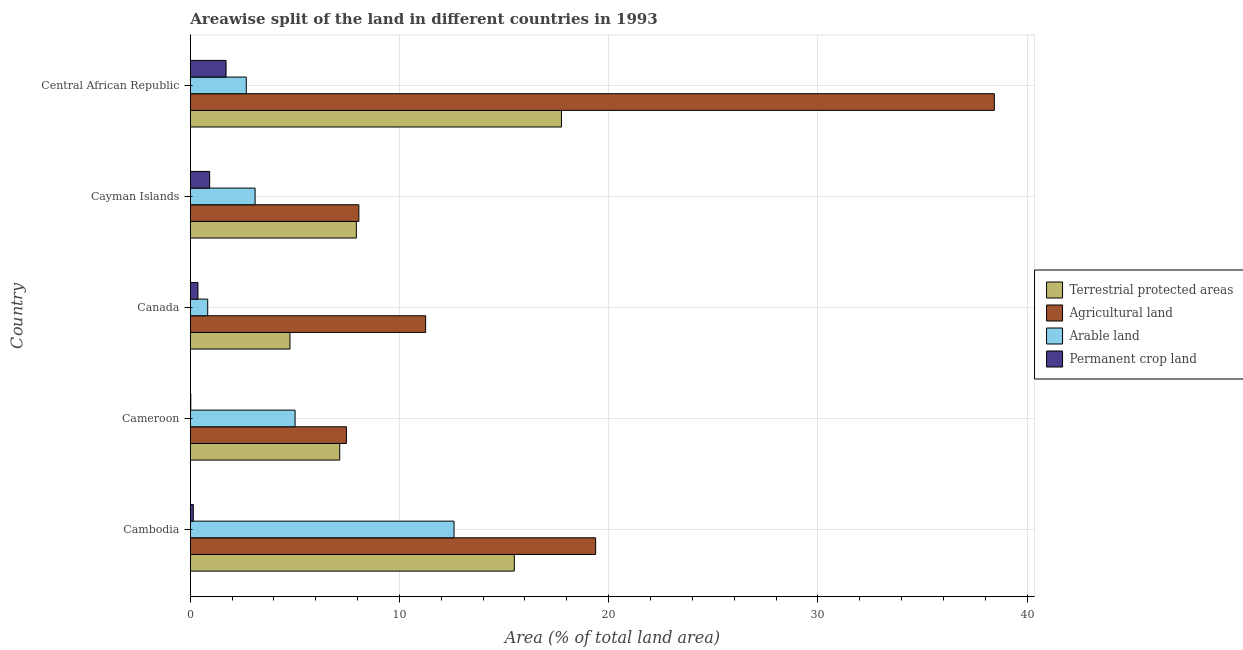How many different coloured bars are there?
Your answer should be compact. 4. How many groups of bars are there?
Your answer should be very brief. 5. Are the number of bars per tick equal to the number of legend labels?
Give a very brief answer. Yes. Are the number of bars on each tick of the Y-axis equal?
Keep it short and to the point. Yes. What is the label of the 1st group of bars from the top?
Your response must be concise. Central African Republic. In how many cases, is the number of bars for a given country not equal to the number of legend labels?
Keep it short and to the point. 0. What is the percentage of area under arable land in Cayman Islands?
Keep it short and to the point. 3.1. Across all countries, what is the maximum percentage of area under arable land?
Provide a short and direct response. 12.61. Across all countries, what is the minimum percentage of area under agricultural land?
Offer a terse response. 7.46. In which country was the percentage of area under arable land maximum?
Provide a succinct answer. Cambodia. In which country was the percentage of land under terrestrial protection minimum?
Provide a short and direct response. Canada. What is the total percentage of area under arable land in the graph?
Make the answer very short. 24.23. What is the difference between the percentage of area under agricultural land in Cambodia and that in Canada?
Your answer should be compact. 8.13. What is the difference between the percentage of land under terrestrial protection in Central African Republic and the percentage of area under agricultural land in Cambodia?
Your answer should be compact. -1.63. What is the average percentage of area under permanent crop land per country?
Keep it short and to the point. 0.63. What is the difference between the percentage of land under terrestrial protection and percentage of area under permanent crop land in Canada?
Keep it short and to the point. 4.4. In how many countries, is the percentage of area under agricultural land greater than 22 %?
Give a very brief answer. 1. What is the ratio of the percentage of area under permanent crop land in Canada to that in Central African Republic?
Keep it short and to the point. 0.21. Is the difference between the percentage of area under agricultural land in Canada and Cayman Islands greater than the difference between the percentage of area under arable land in Canada and Cayman Islands?
Give a very brief answer. Yes. What is the difference between the highest and the second highest percentage of area under arable land?
Your answer should be very brief. 7.6. What is the difference between the highest and the lowest percentage of area under agricultural land?
Offer a very short reply. 30.97. Is the sum of the percentage of land under terrestrial protection in Canada and Central African Republic greater than the maximum percentage of area under arable land across all countries?
Offer a terse response. Yes. What does the 1st bar from the top in Cayman Islands represents?
Make the answer very short. Permanent crop land. What does the 3rd bar from the bottom in Canada represents?
Your answer should be compact. Arable land. How many bars are there?
Your answer should be compact. 20. How many countries are there in the graph?
Give a very brief answer. 5. Does the graph contain grids?
Provide a short and direct response. Yes. What is the title of the graph?
Provide a short and direct response. Areawise split of the land in different countries in 1993. What is the label or title of the X-axis?
Make the answer very short. Area (% of total land area). What is the Area (% of total land area) of Terrestrial protected areas in Cambodia?
Your response must be concise. 15.49. What is the Area (% of total land area) of Agricultural land in Cambodia?
Offer a terse response. 19.38. What is the Area (% of total land area) of Arable land in Cambodia?
Provide a succinct answer. 12.61. What is the Area (% of total land area) of Permanent crop land in Cambodia?
Offer a terse response. 0.14. What is the Area (% of total land area) in Terrestrial protected areas in Cameroon?
Provide a succinct answer. 7.14. What is the Area (% of total land area) of Agricultural land in Cameroon?
Provide a succinct answer. 7.46. What is the Area (% of total land area) of Arable land in Cameroon?
Your response must be concise. 5.01. What is the Area (% of total land area) in Permanent crop land in Cameroon?
Your answer should be compact. 0.02. What is the Area (% of total land area) of Terrestrial protected areas in Canada?
Give a very brief answer. 4.77. What is the Area (% of total land area) in Agricultural land in Canada?
Keep it short and to the point. 11.25. What is the Area (% of total land area) in Arable land in Canada?
Make the answer very short. 0.83. What is the Area (% of total land area) of Permanent crop land in Canada?
Your answer should be compact. 0.37. What is the Area (% of total land area) in Terrestrial protected areas in Cayman Islands?
Your answer should be compact. 7.94. What is the Area (% of total land area) in Agricultural land in Cayman Islands?
Make the answer very short. 8.06. What is the Area (% of total land area) in Arable land in Cayman Islands?
Make the answer very short. 3.1. What is the Area (% of total land area) in Permanent crop land in Cayman Islands?
Keep it short and to the point. 0.93. What is the Area (% of total land area) of Terrestrial protected areas in Central African Republic?
Offer a terse response. 17.74. What is the Area (% of total land area) of Agricultural land in Central African Republic?
Your response must be concise. 38.44. What is the Area (% of total land area) of Arable land in Central African Republic?
Provide a short and direct response. 2.68. What is the Area (% of total land area) in Permanent crop land in Central African Republic?
Keep it short and to the point. 1.71. Across all countries, what is the maximum Area (% of total land area) in Terrestrial protected areas?
Keep it short and to the point. 17.74. Across all countries, what is the maximum Area (% of total land area) in Agricultural land?
Make the answer very short. 38.44. Across all countries, what is the maximum Area (% of total land area) in Arable land?
Your answer should be compact. 12.61. Across all countries, what is the maximum Area (% of total land area) of Permanent crop land?
Give a very brief answer. 1.71. Across all countries, what is the minimum Area (% of total land area) of Terrestrial protected areas?
Ensure brevity in your answer.  4.77. Across all countries, what is the minimum Area (% of total land area) in Agricultural land?
Provide a short and direct response. 7.46. Across all countries, what is the minimum Area (% of total land area) of Arable land?
Your answer should be very brief. 0.83. Across all countries, what is the minimum Area (% of total land area) of Permanent crop land?
Your answer should be very brief. 0.02. What is the total Area (% of total land area) of Terrestrial protected areas in the graph?
Your answer should be very brief. 53.08. What is the total Area (% of total land area) of Agricultural land in the graph?
Offer a terse response. 84.59. What is the total Area (% of total land area) in Arable land in the graph?
Make the answer very short. 24.23. What is the total Area (% of total land area) of Permanent crop land in the graph?
Give a very brief answer. 3.17. What is the difference between the Area (% of total land area) in Terrestrial protected areas in Cambodia and that in Cameroon?
Offer a terse response. 8.35. What is the difference between the Area (% of total land area) in Agricultural land in Cambodia and that in Cameroon?
Provide a succinct answer. 11.91. What is the difference between the Area (% of total land area) in Arable land in Cambodia and that in Cameroon?
Make the answer very short. 7.6. What is the difference between the Area (% of total land area) of Permanent crop land in Cambodia and that in Cameroon?
Offer a very short reply. 0.12. What is the difference between the Area (% of total land area) in Terrestrial protected areas in Cambodia and that in Canada?
Keep it short and to the point. 10.72. What is the difference between the Area (% of total land area) in Agricultural land in Cambodia and that in Canada?
Offer a very short reply. 8.13. What is the difference between the Area (% of total land area) of Arable land in Cambodia and that in Canada?
Ensure brevity in your answer.  11.77. What is the difference between the Area (% of total land area) of Permanent crop land in Cambodia and that in Canada?
Keep it short and to the point. -0.22. What is the difference between the Area (% of total land area) in Terrestrial protected areas in Cambodia and that in Cayman Islands?
Your answer should be very brief. 7.55. What is the difference between the Area (% of total land area) in Agricultural land in Cambodia and that in Cayman Islands?
Offer a very short reply. 11.32. What is the difference between the Area (% of total land area) in Arable land in Cambodia and that in Cayman Islands?
Ensure brevity in your answer.  9.51. What is the difference between the Area (% of total land area) in Permanent crop land in Cambodia and that in Cayman Islands?
Give a very brief answer. -0.78. What is the difference between the Area (% of total land area) in Terrestrial protected areas in Cambodia and that in Central African Republic?
Your response must be concise. -2.25. What is the difference between the Area (% of total land area) of Agricultural land in Cambodia and that in Central African Republic?
Your answer should be very brief. -19.06. What is the difference between the Area (% of total land area) of Arable land in Cambodia and that in Central African Republic?
Provide a short and direct response. 9.93. What is the difference between the Area (% of total land area) of Permanent crop land in Cambodia and that in Central African Republic?
Ensure brevity in your answer.  -1.57. What is the difference between the Area (% of total land area) in Terrestrial protected areas in Cameroon and that in Canada?
Provide a short and direct response. 2.38. What is the difference between the Area (% of total land area) of Agricultural land in Cameroon and that in Canada?
Your answer should be compact. -3.79. What is the difference between the Area (% of total land area) of Arable land in Cameroon and that in Canada?
Your answer should be compact. 4.18. What is the difference between the Area (% of total land area) in Permanent crop land in Cameroon and that in Canada?
Make the answer very short. -0.34. What is the difference between the Area (% of total land area) in Terrestrial protected areas in Cameroon and that in Cayman Islands?
Your answer should be very brief. -0.79. What is the difference between the Area (% of total land area) in Agricultural land in Cameroon and that in Cayman Islands?
Ensure brevity in your answer.  -0.59. What is the difference between the Area (% of total land area) in Arable land in Cameroon and that in Cayman Islands?
Offer a very short reply. 1.91. What is the difference between the Area (% of total land area) of Permanent crop land in Cameroon and that in Cayman Islands?
Your response must be concise. -0.9. What is the difference between the Area (% of total land area) of Terrestrial protected areas in Cameroon and that in Central African Republic?
Your response must be concise. -10.6. What is the difference between the Area (% of total land area) of Agricultural land in Cameroon and that in Central African Republic?
Keep it short and to the point. -30.97. What is the difference between the Area (% of total land area) in Arable land in Cameroon and that in Central African Republic?
Your answer should be very brief. 2.33. What is the difference between the Area (% of total land area) of Permanent crop land in Cameroon and that in Central African Republic?
Ensure brevity in your answer.  -1.69. What is the difference between the Area (% of total land area) in Terrestrial protected areas in Canada and that in Cayman Islands?
Your answer should be compact. -3.17. What is the difference between the Area (% of total land area) of Agricultural land in Canada and that in Cayman Islands?
Keep it short and to the point. 3.19. What is the difference between the Area (% of total land area) in Arable land in Canada and that in Cayman Islands?
Ensure brevity in your answer.  -2.26. What is the difference between the Area (% of total land area) in Permanent crop land in Canada and that in Cayman Islands?
Ensure brevity in your answer.  -0.56. What is the difference between the Area (% of total land area) in Terrestrial protected areas in Canada and that in Central African Republic?
Offer a very short reply. -12.98. What is the difference between the Area (% of total land area) in Agricultural land in Canada and that in Central African Republic?
Ensure brevity in your answer.  -27.19. What is the difference between the Area (% of total land area) of Arable land in Canada and that in Central African Republic?
Your answer should be very brief. -1.84. What is the difference between the Area (% of total land area) in Permanent crop land in Canada and that in Central African Republic?
Provide a short and direct response. -1.34. What is the difference between the Area (% of total land area) in Terrestrial protected areas in Cayman Islands and that in Central African Republic?
Offer a very short reply. -9.81. What is the difference between the Area (% of total land area) in Agricultural land in Cayman Islands and that in Central African Republic?
Offer a terse response. -30.38. What is the difference between the Area (% of total land area) of Arable land in Cayman Islands and that in Central African Republic?
Make the answer very short. 0.42. What is the difference between the Area (% of total land area) of Permanent crop land in Cayman Islands and that in Central African Republic?
Provide a short and direct response. -0.78. What is the difference between the Area (% of total land area) in Terrestrial protected areas in Cambodia and the Area (% of total land area) in Agricultural land in Cameroon?
Keep it short and to the point. 8.03. What is the difference between the Area (% of total land area) in Terrestrial protected areas in Cambodia and the Area (% of total land area) in Arable land in Cameroon?
Your answer should be compact. 10.48. What is the difference between the Area (% of total land area) in Terrestrial protected areas in Cambodia and the Area (% of total land area) in Permanent crop land in Cameroon?
Give a very brief answer. 15.47. What is the difference between the Area (% of total land area) of Agricultural land in Cambodia and the Area (% of total land area) of Arable land in Cameroon?
Your answer should be compact. 14.37. What is the difference between the Area (% of total land area) of Agricultural land in Cambodia and the Area (% of total land area) of Permanent crop land in Cameroon?
Give a very brief answer. 19.35. What is the difference between the Area (% of total land area) in Arable land in Cambodia and the Area (% of total land area) in Permanent crop land in Cameroon?
Your answer should be very brief. 12.58. What is the difference between the Area (% of total land area) in Terrestrial protected areas in Cambodia and the Area (% of total land area) in Agricultural land in Canada?
Your answer should be very brief. 4.24. What is the difference between the Area (% of total land area) in Terrestrial protected areas in Cambodia and the Area (% of total land area) in Arable land in Canada?
Make the answer very short. 14.66. What is the difference between the Area (% of total land area) of Terrestrial protected areas in Cambodia and the Area (% of total land area) of Permanent crop land in Canada?
Your answer should be compact. 15.12. What is the difference between the Area (% of total land area) of Agricultural land in Cambodia and the Area (% of total land area) of Arable land in Canada?
Your answer should be very brief. 18.54. What is the difference between the Area (% of total land area) in Agricultural land in Cambodia and the Area (% of total land area) in Permanent crop land in Canada?
Provide a short and direct response. 19.01. What is the difference between the Area (% of total land area) of Arable land in Cambodia and the Area (% of total land area) of Permanent crop land in Canada?
Make the answer very short. 12.24. What is the difference between the Area (% of total land area) in Terrestrial protected areas in Cambodia and the Area (% of total land area) in Agricultural land in Cayman Islands?
Keep it short and to the point. 7.43. What is the difference between the Area (% of total land area) of Terrestrial protected areas in Cambodia and the Area (% of total land area) of Arable land in Cayman Islands?
Provide a short and direct response. 12.39. What is the difference between the Area (% of total land area) in Terrestrial protected areas in Cambodia and the Area (% of total land area) in Permanent crop land in Cayman Islands?
Offer a terse response. 14.56. What is the difference between the Area (% of total land area) in Agricultural land in Cambodia and the Area (% of total land area) in Arable land in Cayman Islands?
Your response must be concise. 16.28. What is the difference between the Area (% of total land area) in Agricultural land in Cambodia and the Area (% of total land area) in Permanent crop land in Cayman Islands?
Offer a very short reply. 18.45. What is the difference between the Area (% of total land area) of Arable land in Cambodia and the Area (% of total land area) of Permanent crop land in Cayman Islands?
Your answer should be very brief. 11.68. What is the difference between the Area (% of total land area) of Terrestrial protected areas in Cambodia and the Area (% of total land area) of Agricultural land in Central African Republic?
Ensure brevity in your answer.  -22.95. What is the difference between the Area (% of total land area) of Terrestrial protected areas in Cambodia and the Area (% of total land area) of Arable land in Central African Republic?
Provide a short and direct response. 12.81. What is the difference between the Area (% of total land area) of Terrestrial protected areas in Cambodia and the Area (% of total land area) of Permanent crop land in Central African Republic?
Your response must be concise. 13.78. What is the difference between the Area (% of total land area) of Agricultural land in Cambodia and the Area (% of total land area) of Arable land in Central African Republic?
Provide a short and direct response. 16.7. What is the difference between the Area (% of total land area) of Agricultural land in Cambodia and the Area (% of total land area) of Permanent crop land in Central African Republic?
Make the answer very short. 17.67. What is the difference between the Area (% of total land area) in Arable land in Cambodia and the Area (% of total land area) in Permanent crop land in Central African Republic?
Your answer should be very brief. 10.9. What is the difference between the Area (% of total land area) in Terrestrial protected areas in Cameroon and the Area (% of total land area) in Agricultural land in Canada?
Keep it short and to the point. -4.11. What is the difference between the Area (% of total land area) of Terrestrial protected areas in Cameroon and the Area (% of total land area) of Arable land in Canada?
Provide a short and direct response. 6.31. What is the difference between the Area (% of total land area) in Terrestrial protected areas in Cameroon and the Area (% of total land area) in Permanent crop land in Canada?
Ensure brevity in your answer.  6.78. What is the difference between the Area (% of total land area) of Agricultural land in Cameroon and the Area (% of total land area) of Arable land in Canada?
Your answer should be very brief. 6.63. What is the difference between the Area (% of total land area) of Agricultural land in Cameroon and the Area (% of total land area) of Permanent crop land in Canada?
Provide a succinct answer. 7.1. What is the difference between the Area (% of total land area) in Arable land in Cameroon and the Area (% of total land area) in Permanent crop land in Canada?
Provide a short and direct response. 4.64. What is the difference between the Area (% of total land area) in Terrestrial protected areas in Cameroon and the Area (% of total land area) in Agricultural land in Cayman Islands?
Give a very brief answer. -0.91. What is the difference between the Area (% of total land area) in Terrestrial protected areas in Cameroon and the Area (% of total land area) in Arable land in Cayman Islands?
Your answer should be compact. 4.05. What is the difference between the Area (% of total land area) of Terrestrial protected areas in Cameroon and the Area (% of total land area) of Permanent crop land in Cayman Islands?
Keep it short and to the point. 6.22. What is the difference between the Area (% of total land area) in Agricultural land in Cameroon and the Area (% of total land area) in Arable land in Cayman Islands?
Provide a succinct answer. 4.37. What is the difference between the Area (% of total land area) of Agricultural land in Cameroon and the Area (% of total land area) of Permanent crop land in Cayman Islands?
Keep it short and to the point. 6.54. What is the difference between the Area (% of total land area) in Arable land in Cameroon and the Area (% of total land area) in Permanent crop land in Cayman Islands?
Your answer should be very brief. 4.08. What is the difference between the Area (% of total land area) of Terrestrial protected areas in Cameroon and the Area (% of total land area) of Agricultural land in Central African Republic?
Ensure brevity in your answer.  -31.29. What is the difference between the Area (% of total land area) of Terrestrial protected areas in Cameroon and the Area (% of total land area) of Arable land in Central African Republic?
Provide a succinct answer. 4.47. What is the difference between the Area (% of total land area) in Terrestrial protected areas in Cameroon and the Area (% of total land area) in Permanent crop land in Central African Republic?
Provide a short and direct response. 5.43. What is the difference between the Area (% of total land area) in Agricultural land in Cameroon and the Area (% of total land area) in Arable land in Central African Republic?
Offer a terse response. 4.79. What is the difference between the Area (% of total land area) of Agricultural land in Cameroon and the Area (% of total land area) of Permanent crop land in Central African Republic?
Your answer should be compact. 5.75. What is the difference between the Area (% of total land area) in Arable land in Cameroon and the Area (% of total land area) in Permanent crop land in Central African Republic?
Provide a short and direct response. 3.3. What is the difference between the Area (% of total land area) in Terrestrial protected areas in Canada and the Area (% of total land area) in Agricultural land in Cayman Islands?
Provide a short and direct response. -3.29. What is the difference between the Area (% of total land area) of Terrestrial protected areas in Canada and the Area (% of total land area) of Arable land in Cayman Islands?
Offer a very short reply. 1.67. What is the difference between the Area (% of total land area) of Terrestrial protected areas in Canada and the Area (% of total land area) of Permanent crop land in Cayman Islands?
Make the answer very short. 3.84. What is the difference between the Area (% of total land area) of Agricultural land in Canada and the Area (% of total land area) of Arable land in Cayman Islands?
Keep it short and to the point. 8.15. What is the difference between the Area (% of total land area) of Agricultural land in Canada and the Area (% of total land area) of Permanent crop land in Cayman Islands?
Offer a terse response. 10.32. What is the difference between the Area (% of total land area) in Arable land in Canada and the Area (% of total land area) in Permanent crop land in Cayman Islands?
Provide a short and direct response. -0.09. What is the difference between the Area (% of total land area) in Terrestrial protected areas in Canada and the Area (% of total land area) in Agricultural land in Central African Republic?
Make the answer very short. -33.67. What is the difference between the Area (% of total land area) in Terrestrial protected areas in Canada and the Area (% of total land area) in Arable land in Central African Republic?
Keep it short and to the point. 2.09. What is the difference between the Area (% of total land area) in Terrestrial protected areas in Canada and the Area (% of total land area) in Permanent crop land in Central African Republic?
Ensure brevity in your answer.  3.06. What is the difference between the Area (% of total land area) of Agricultural land in Canada and the Area (% of total land area) of Arable land in Central African Republic?
Ensure brevity in your answer.  8.57. What is the difference between the Area (% of total land area) in Agricultural land in Canada and the Area (% of total land area) in Permanent crop land in Central African Republic?
Your answer should be very brief. 9.54. What is the difference between the Area (% of total land area) in Arable land in Canada and the Area (% of total land area) in Permanent crop land in Central African Republic?
Give a very brief answer. -0.88. What is the difference between the Area (% of total land area) in Terrestrial protected areas in Cayman Islands and the Area (% of total land area) in Agricultural land in Central African Republic?
Your answer should be very brief. -30.5. What is the difference between the Area (% of total land area) in Terrestrial protected areas in Cayman Islands and the Area (% of total land area) in Arable land in Central African Republic?
Make the answer very short. 5.26. What is the difference between the Area (% of total land area) of Terrestrial protected areas in Cayman Islands and the Area (% of total land area) of Permanent crop land in Central African Republic?
Your answer should be compact. 6.23. What is the difference between the Area (% of total land area) in Agricultural land in Cayman Islands and the Area (% of total land area) in Arable land in Central African Republic?
Make the answer very short. 5.38. What is the difference between the Area (% of total land area) in Agricultural land in Cayman Islands and the Area (% of total land area) in Permanent crop land in Central African Republic?
Make the answer very short. 6.35. What is the difference between the Area (% of total land area) of Arable land in Cayman Islands and the Area (% of total land area) of Permanent crop land in Central African Republic?
Make the answer very short. 1.39. What is the average Area (% of total land area) of Terrestrial protected areas per country?
Ensure brevity in your answer.  10.62. What is the average Area (% of total land area) in Agricultural land per country?
Your answer should be compact. 16.92. What is the average Area (% of total land area) of Arable land per country?
Your answer should be compact. 4.84. What is the average Area (% of total land area) in Permanent crop land per country?
Give a very brief answer. 0.63. What is the difference between the Area (% of total land area) in Terrestrial protected areas and Area (% of total land area) in Agricultural land in Cambodia?
Give a very brief answer. -3.89. What is the difference between the Area (% of total land area) in Terrestrial protected areas and Area (% of total land area) in Arable land in Cambodia?
Make the answer very short. 2.88. What is the difference between the Area (% of total land area) in Terrestrial protected areas and Area (% of total land area) in Permanent crop land in Cambodia?
Make the answer very short. 15.35. What is the difference between the Area (% of total land area) in Agricultural land and Area (% of total land area) in Arable land in Cambodia?
Your response must be concise. 6.77. What is the difference between the Area (% of total land area) in Agricultural land and Area (% of total land area) in Permanent crop land in Cambodia?
Give a very brief answer. 19.23. What is the difference between the Area (% of total land area) of Arable land and Area (% of total land area) of Permanent crop land in Cambodia?
Your answer should be very brief. 12.46. What is the difference between the Area (% of total land area) of Terrestrial protected areas and Area (% of total land area) of Agricultural land in Cameroon?
Keep it short and to the point. -0.32. What is the difference between the Area (% of total land area) in Terrestrial protected areas and Area (% of total land area) in Arable land in Cameroon?
Give a very brief answer. 2.13. What is the difference between the Area (% of total land area) of Terrestrial protected areas and Area (% of total land area) of Permanent crop land in Cameroon?
Make the answer very short. 7.12. What is the difference between the Area (% of total land area) in Agricultural land and Area (% of total land area) in Arable land in Cameroon?
Offer a very short reply. 2.45. What is the difference between the Area (% of total land area) in Agricultural land and Area (% of total land area) in Permanent crop land in Cameroon?
Make the answer very short. 7.44. What is the difference between the Area (% of total land area) in Arable land and Area (% of total land area) in Permanent crop land in Cameroon?
Provide a short and direct response. 4.99. What is the difference between the Area (% of total land area) of Terrestrial protected areas and Area (% of total land area) of Agricultural land in Canada?
Ensure brevity in your answer.  -6.49. What is the difference between the Area (% of total land area) in Terrestrial protected areas and Area (% of total land area) in Arable land in Canada?
Ensure brevity in your answer.  3.93. What is the difference between the Area (% of total land area) in Terrestrial protected areas and Area (% of total land area) in Permanent crop land in Canada?
Provide a succinct answer. 4.4. What is the difference between the Area (% of total land area) in Agricultural land and Area (% of total land area) in Arable land in Canada?
Offer a very short reply. 10.42. What is the difference between the Area (% of total land area) of Agricultural land and Area (% of total land area) of Permanent crop land in Canada?
Your answer should be very brief. 10.88. What is the difference between the Area (% of total land area) of Arable land and Area (% of total land area) of Permanent crop land in Canada?
Offer a very short reply. 0.47. What is the difference between the Area (% of total land area) in Terrestrial protected areas and Area (% of total land area) in Agricultural land in Cayman Islands?
Give a very brief answer. -0.12. What is the difference between the Area (% of total land area) in Terrestrial protected areas and Area (% of total land area) in Arable land in Cayman Islands?
Your answer should be compact. 4.84. What is the difference between the Area (% of total land area) of Terrestrial protected areas and Area (% of total land area) of Permanent crop land in Cayman Islands?
Provide a succinct answer. 7.01. What is the difference between the Area (% of total land area) in Agricultural land and Area (% of total land area) in Arable land in Cayman Islands?
Your answer should be compact. 4.96. What is the difference between the Area (% of total land area) in Agricultural land and Area (% of total land area) in Permanent crop land in Cayman Islands?
Provide a short and direct response. 7.13. What is the difference between the Area (% of total land area) of Arable land and Area (% of total land area) of Permanent crop land in Cayman Islands?
Your response must be concise. 2.17. What is the difference between the Area (% of total land area) of Terrestrial protected areas and Area (% of total land area) of Agricultural land in Central African Republic?
Your answer should be compact. -20.69. What is the difference between the Area (% of total land area) of Terrestrial protected areas and Area (% of total land area) of Arable land in Central African Republic?
Provide a short and direct response. 15.07. What is the difference between the Area (% of total land area) in Terrestrial protected areas and Area (% of total land area) in Permanent crop land in Central African Republic?
Your answer should be very brief. 16.03. What is the difference between the Area (% of total land area) of Agricultural land and Area (% of total land area) of Arable land in Central African Republic?
Provide a short and direct response. 35.76. What is the difference between the Area (% of total land area) of Agricultural land and Area (% of total land area) of Permanent crop land in Central African Republic?
Offer a terse response. 36.73. What is the difference between the Area (% of total land area) in Arable land and Area (% of total land area) in Permanent crop land in Central African Republic?
Provide a short and direct response. 0.97. What is the ratio of the Area (% of total land area) in Terrestrial protected areas in Cambodia to that in Cameroon?
Keep it short and to the point. 2.17. What is the ratio of the Area (% of total land area) of Agricultural land in Cambodia to that in Cameroon?
Ensure brevity in your answer.  2.6. What is the ratio of the Area (% of total land area) in Arable land in Cambodia to that in Cameroon?
Provide a short and direct response. 2.52. What is the ratio of the Area (% of total land area) in Permanent crop land in Cambodia to that in Cameroon?
Offer a terse response. 6.06. What is the ratio of the Area (% of total land area) in Terrestrial protected areas in Cambodia to that in Canada?
Offer a very short reply. 3.25. What is the ratio of the Area (% of total land area) in Agricultural land in Cambodia to that in Canada?
Your answer should be compact. 1.72. What is the ratio of the Area (% of total land area) in Arable land in Cambodia to that in Canada?
Your answer should be compact. 15.13. What is the ratio of the Area (% of total land area) of Permanent crop land in Cambodia to that in Canada?
Give a very brief answer. 0.39. What is the ratio of the Area (% of total land area) of Terrestrial protected areas in Cambodia to that in Cayman Islands?
Provide a succinct answer. 1.95. What is the ratio of the Area (% of total land area) in Agricultural land in Cambodia to that in Cayman Islands?
Offer a very short reply. 2.4. What is the ratio of the Area (% of total land area) of Arable land in Cambodia to that in Cayman Islands?
Give a very brief answer. 4.07. What is the ratio of the Area (% of total land area) in Permanent crop land in Cambodia to that in Cayman Islands?
Make the answer very short. 0.16. What is the ratio of the Area (% of total land area) in Terrestrial protected areas in Cambodia to that in Central African Republic?
Offer a very short reply. 0.87. What is the ratio of the Area (% of total land area) of Agricultural land in Cambodia to that in Central African Republic?
Provide a short and direct response. 0.5. What is the ratio of the Area (% of total land area) of Arable land in Cambodia to that in Central African Republic?
Offer a terse response. 4.71. What is the ratio of the Area (% of total land area) of Permanent crop land in Cambodia to that in Central African Republic?
Make the answer very short. 0.08. What is the ratio of the Area (% of total land area) of Terrestrial protected areas in Cameroon to that in Canada?
Give a very brief answer. 1.5. What is the ratio of the Area (% of total land area) in Agricultural land in Cameroon to that in Canada?
Your answer should be very brief. 0.66. What is the ratio of the Area (% of total land area) in Arable land in Cameroon to that in Canada?
Your answer should be very brief. 6.01. What is the ratio of the Area (% of total land area) in Permanent crop land in Cameroon to that in Canada?
Keep it short and to the point. 0.06. What is the ratio of the Area (% of total land area) of Terrestrial protected areas in Cameroon to that in Cayman Islands?
Give a very brief answer. 0.9. What is the ratio of the Area (% of total land area) of Agricultural land in Cameroon to that in Cayman Islands?
Your response must be concise. 0.93. What is the ratio of the Area (% of total land area) in Arable land in Cameroon to that in Cayman Islands?
Give a very brief answer. 1.62. What is the ratio of the Area (% of total land area) of Permanent crop land in Cameroon to that in Cayman Islands?
Keep it short and to the point. 0.03. What is the ratio of the Area (% of total land area) in Terrestrial protected areas in Cameroon to that in Central African Republic?
Offer a very short reply. 0.4. What is the ratio of the Area (% of total land area) in Agricultural land in Cameroon to that in Central African Republic?
Provide a short and direct response. 0.19. What is the ratio of the Area (% of total land area) in Arable land in Cameroon to that in Central African Republic?
Provide a succinct answer. 1.87. What is the ratio of the Area (% of total land area) in Permanent crop land in Cameroon to that in Central African Republic?
Keep it short and to the point. 0.01. What is the ratio of the Area (% of total land area) in Terrestrial protected areas in Canada to that in Cayman Islands?
Provide a succinct answer. 0.6. What is the ratio of the Area (% of total land area) in Agricultural land in Canada to that in Cayman Islands?
Keep it short and to the point. 1.4. What is the ratio of the Area (% of total land area) of Arable land in Canada to that in Cayman Islands?
Provide a short and direct response. 0.27. What is the ratio of the Area (% of total land area) in Permanent crop land in Canada to that in Cayman Islands?
Offer a terse response. 0.4. What is the ratio of the Area (% of total land area) of Terrestrial protected areas in Canada to that in Central African Republic?
Your answer should be very brief. 0.27. What is the ratio of the Area (% of total land area) of Agricultural land in Canada to that in Central African Republic?
Your answer should be compact. 0.29. What is the ratio of the Area (% of total land area) of Arable land in Canada to that in Central African Republic?
Offer a terse response. 0.31. What is the ratio of the Area (% of total land area) in Permanent crop land in Canada to that in Central African Republic?
Ensure brevity in your answer.  0.21. What is the ratio of the Area (% of total land area) of Terrestrial protected areas in Cayman Islands to that in Central African Republic?
Your answer should be very brief. 0.45. What is the ratio of the Area (% of total land area) of Agricultural land in Cayman Islands to that in Central African Republic?
Give a very brief answer. 0.21. What is the ratio of the Area (% of total land area) of Arable land in Cayman Islands to that in Central African Republic?
Keep it short and to the point. 1.16. What is the ratio of the Area (% of total land area) of Permanent crop land in Cayman Islands to that in Central African Republic?
Give a very brief answer. 0.54. What is the difference between the highest and the second highest Area (% of total land area) in Terrestrial protected areas?
Offer a terse response. 2.25. What is the difference between the highest and the second highest Area (% of total land area) in Agricultural land?
Keep it short and to the point. 19.06. What is the difference between the highest and the second highest Area (% of total land area) in Arable land?
Make the answer very short. 7.6. What is the difference between the highest and the second highest Area (% of total land area) of Permanent crop land?
Your answer should be very brief. 0.78. What is the difference between the highest and the lowest Area (% of total land area) in Terrestrial protected areas?
Your answer should be compact. 12.98. What is the difference between the highest and the lowest Area (% of total land area) in Agricultural land?
Make the answer very short. 30.97. What is the difference between the highest and the lowest Area (% of total land area) of Arable land?
Your answer should be compact. 11.77. What is the difference between the highest and the lowest Area (% of total land area) of Permanent crop land?
Provide a succinct answer. 1.69. 